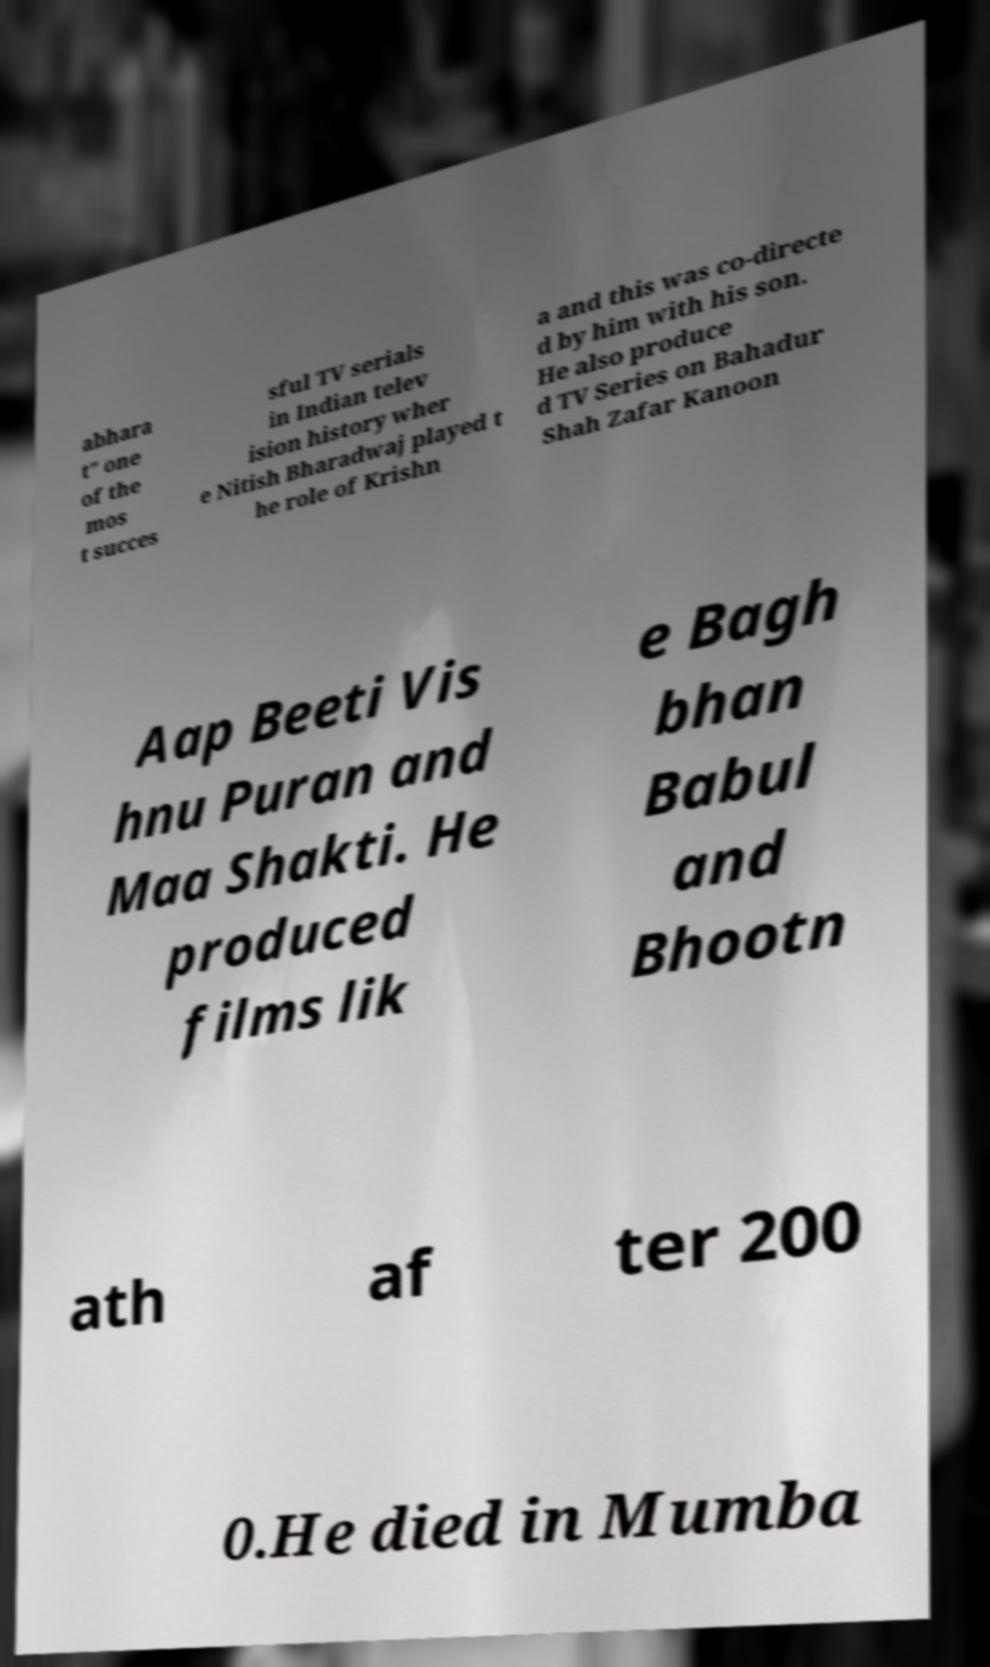Can you accurately transcribe the text from the provided image for me? abhara t" one of the mos t succes sful TV serials in Indian telev ision history wher e Nitish Bharadwaj played t he role of Krishn a and this was co-directe d by him with his son. He also produce d TV Series on Bahadur Shah Zafar Kanoon Aap Beeti Vis hnu Puran and Maa Shakti. He produced films lik e Bagh bhan Babul and Bhootn ath af ter 200 0.He died in Mumba 